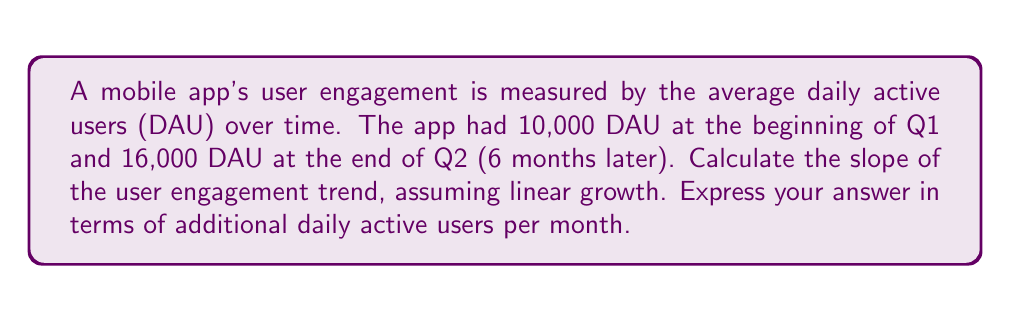What is the answer to this math problem? To calculate the slope of the user engagement trend, we'll use the formula for slope:

$$ m = \frac{y_2 - y_1}{x_2 - x_1} $$

Where:
$m$ = slope
$y_2$ = final DAU value
$y_1$ = initial DAU value
$x_2$ = final time point
$x_1$ = initial time point

Given:
- Initial DAU (y1) = 10,000
- Final DAU (y2) = 16,000
- Time difference = 6 months

Step 1: Plug the values into the slope formula
$$ m = \frac{16,000 - 10,000}{6 - 0} = \frac{6,000}{6} $$

Step 2: Simplify
$$ m = 1,000 $$

The slope represents the increase in DAU per month, which is 1,000 additional daily active users per month.
Answer: 1,000 DAU/month 